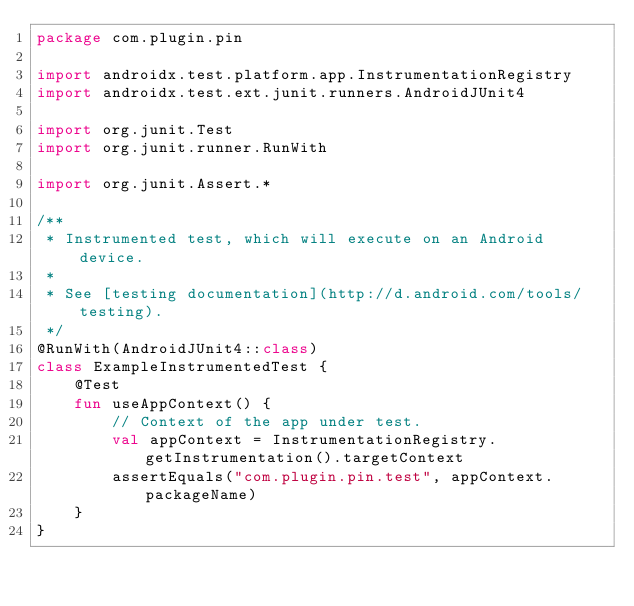Convert code to text. <code><loc_0><loc_0><loc_500><loc_500><_Kotlin_>package com.plugin.pin

import androidx.test.platform.app.InstrumentationRegistry
import androidx.test.ext.junit.runners.AndroidJUnit4

import org.junit.Test
import org.junit.runner.RunWith

import org.junit.Assert.*

/**
 * Instrumented test, which will execute on an Android device.
 *
 * See [testing documentation](http://d.android.com/tools/testing).
 */
@RunWith(AndroidJUnit4::class)
class ExampleInstrumentedTest {
    @Test
    fun useAppContext() {
        // Context of the app under test.
        val appContext = InstrumentationRegistry.getInstrumentation().targetContext
        assertEquals("com.plugin.pin.test", appContext.packageName)
    }
}
</code> 